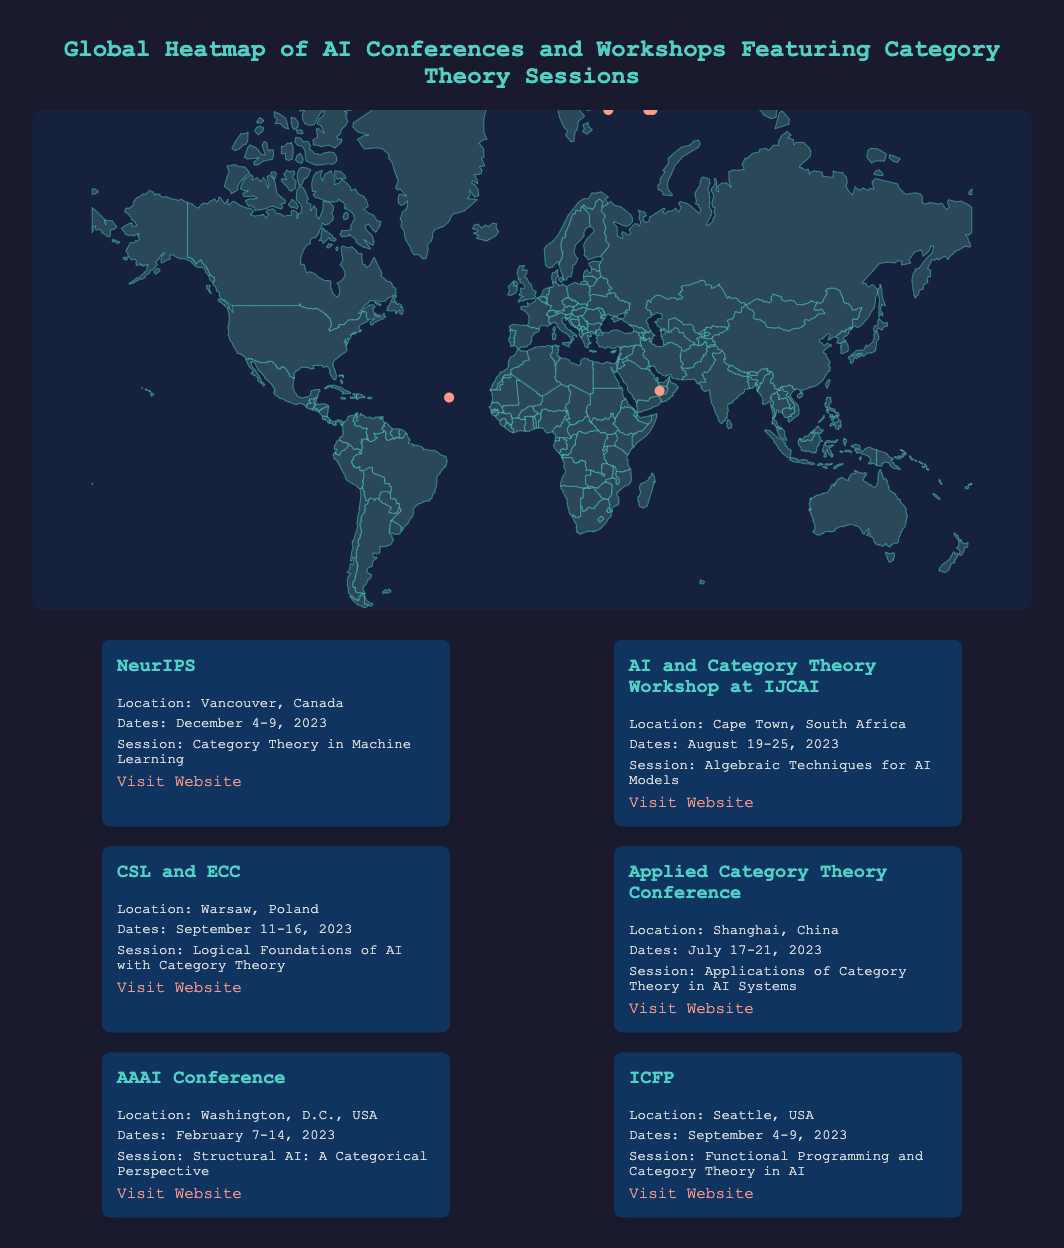What is the title of the infographic? The title of the infographic is displayed prominently at the top of the document.
Answer: Global Heatmap of AI Conferences and Workshops Featuring Category Theory Sessions How many conferences include Category Theory sessions? The document lists specific conferences that feature Category Theory sessions.
Answer: Six What city will NeurIPS take place in? The event card for NeurIPS specifies the location of the conference.
Answer: Vancouver, Canada Which conference is scheduled for December 2023? The date for NeurIPS is provided in its event card along with its location.
Answer: NeurIPS What is the date range for the AI and Category Theory Workshop at IJCAI? The event card for the AI and Category Theory Workshop at IJCAI includes specific dates.
Answer: August 19-25, 2023 What is the main session topic for the AAAI Conference? The event card for the AAAI Conference states its session topic.
Answer: Structural AI: A Categorical Perspective What color represents the countries on the heatmap? The heatmap's fill color for countries is specified in the SVG style attributes.
Answer: Dark blue Which conference has a session about algebraic techniques for AI models? The session information for each conference is included in the respective event cards.
Answer: AI and Category Theory Workshop at IJCAI What is the location for the Applied Category Theory Conference? The event card for the Applied Category Theory Conference specifies its location.
Answer: Shanghai, China 